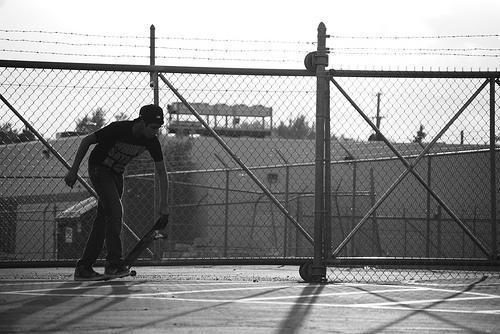How many people are on the picture?
Give a very brief answer. 1. How many people are behind  on the other side of the fence?
Give a very brief answer. 0. 